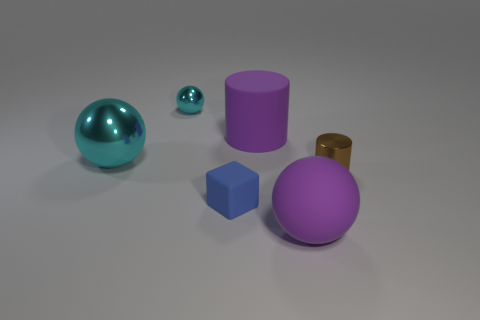What material is the big ball that is on the left side of the big matte thing that is in front of the cyan metal ball in front of the big rubber cylinder?
Offer a very short reply. Metal. Is there any other thing that is the same shape as the small cyan thing?
Provide a short and direct response. Yes. There is another matte object that is the same shape as the big cyan object; what is its color?
Ensure brevity in your answer.  Purple. Do the large sphere in front of the tiny brown metallic cylinder and the metallic object on the right side of the purple cylinder have the same color?
Your answer should be very brief. No. Is the number of things that are in front of the brown metallic thing greater than the number of big purple metallic cubes?
Make the answer very short. Yes. What number of other objects are the same size as the brown thing?
Ensure brevity in your answer.  2. How many spheres are behind the purple cylinder and in front of the large cyan shiny ball?
Make the answer very short. 0. Are the big purple object that is left of the matte ball and the small cylinder made of the same material?
Offer a very short reply. No. There is a purple rubber object that is behind the small metallic object to the right of the purple object that is behind the big purple rubber sphere; what shape is it?
Keep it short and to the point. Cylinder. Are there the same number of big purple objects left of the small cube and tiny shiny balls to the right of the small brown thing?
Keep it short and to the point. Yes. 